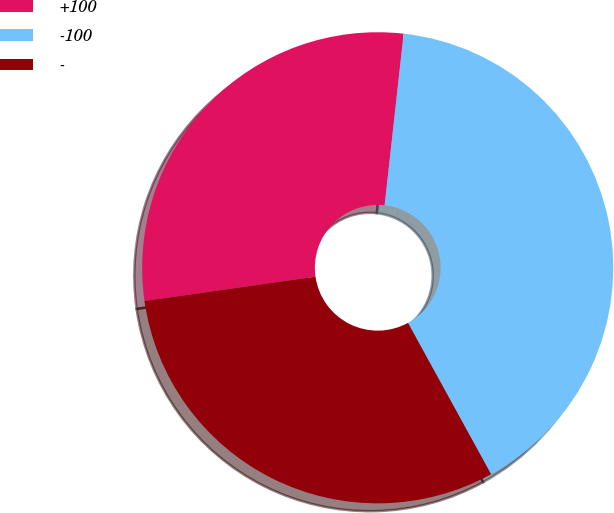Convert chart to OTSL. <chart><loc_0><loc_0><loc_500><loc_500><pie_chart><fcel>+100<fcel>-100<fcel>-<nl><fcel>29.01%<fcel>40.25%<fcel>30.74%<nl></chart> 